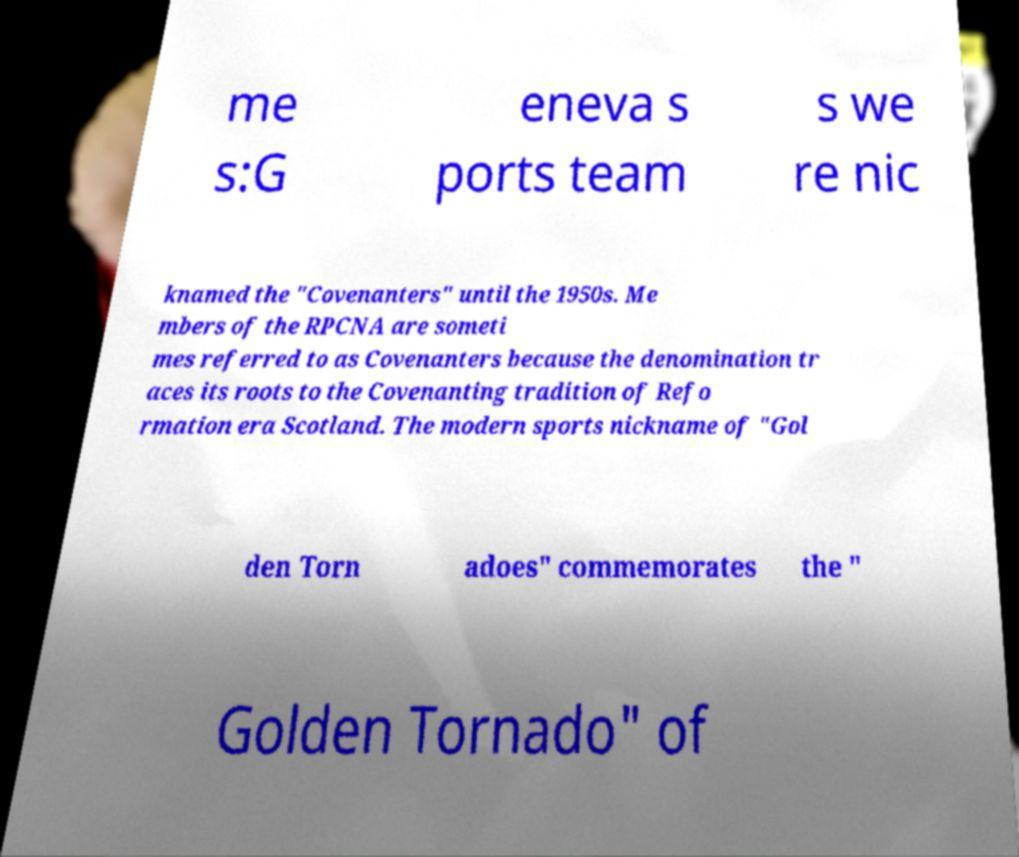Could you extract and type out the text from this image? me s:G eneva s ports team s we re nic knamed the "Covenanters" until the 1950s. Me mbers of the RPCNA are someti mes referred to as Covenanters because the denomination tr aces its roots to the Covenanting tradition of Refo rmation era Scotland. The modern sports nickname of "Gol den Torn adoes" commemorates the " Golden Tornado" of 